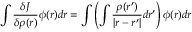<formula> <loc_0><loc_0><loc_500><loc_500>\int { \frac { \delta J } { \delta \rho ( { r } ) } } \phi ( { r } ) d { r } = \int \left ( \int { \frac { \rho ( { r } ^ { \prime } ) } { | { r } - { r } ^ { \prime } | } } d { r } ^ { \prime } \right ) \phi ( { r } ) d { r }</formula> 